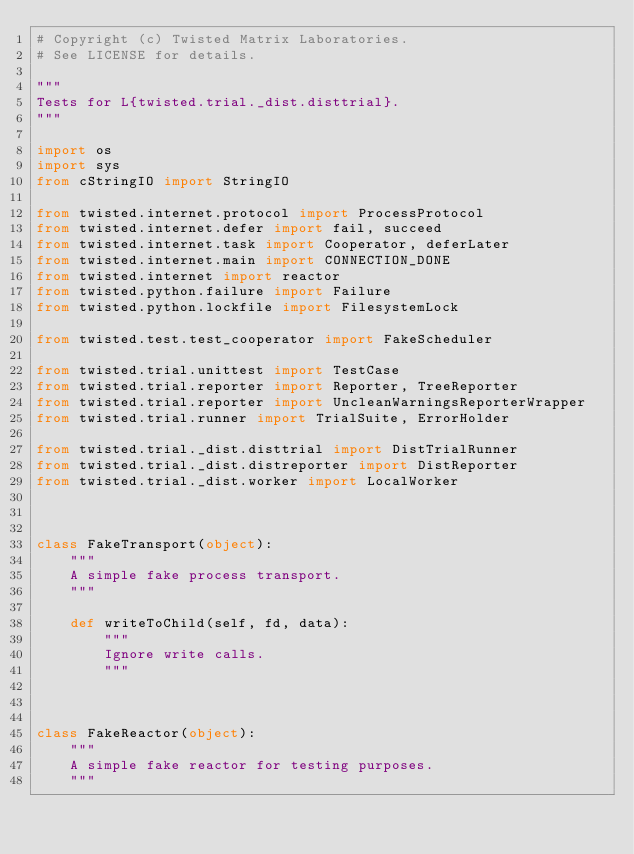Convert code to text. <code><loc_0><loc_0><loc_500><loc_500><_Python_># Copyright (c) Twisted Matrix Laboratories.
# See LICENSE for details.

"""
Tests for L{twisted.trial._dist.disttrial}.
"""

import os
import sys
from cStringIO import StringIO

from twisted.internet.protocol import ProcessProtocol
from twisted.internet.defer import fail, succeed
from twisted.internet.task import Cooperator, deferLater
from twisted.internet.main import CONNECTION_DONE
from twisted.internet import reactor
from twisted.python.failure import Failure
from twisted.python.lockfile import FilesystemLock

from twisted.test.test_cooperator import FakeScheduler

from twisted.trial.unittest import TestCase
from twisted.trial.reporter import Reporter, TreeReporter
from twisted.trial.reporter import UncleanWarningsReporterWrapper
from twisted.trial.runner import TrialSuite, ErrorHolder

from twisted.trial._dist.disttrial import DistTrialRunner
from twisted.trial._dist.distreporter import DistReporter
from twisted.trial._dist.worker import LocalWorker



class FakeTransport(object):
    """
    A simple fake process transport.
    """

    def writeToChild(self, fd, data):
        """
        Ignore write calls.
        """



class FakeReactor(object):
    """
    A simple fake reactor for testing purposes.
    """</code> 